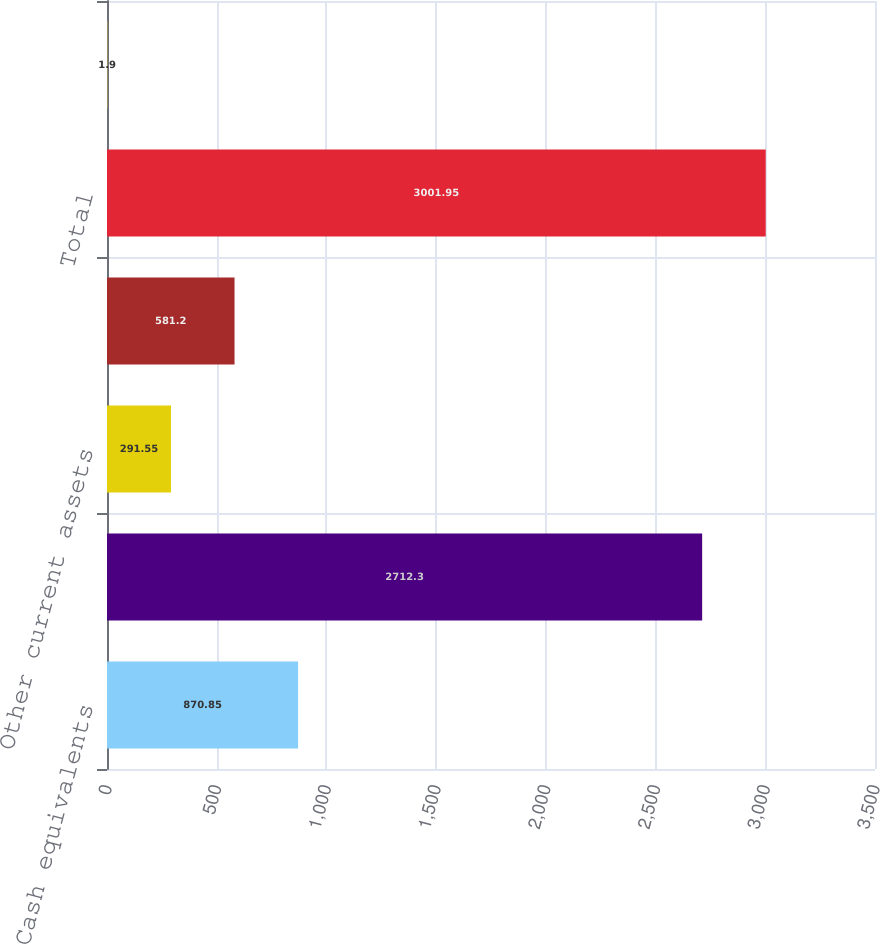<chart> <loc_0><loc_0><loc_500><loc_500><bar_chart><fcel>Cash equivalents<fcel>Short-term investments<fcel>Other current assets<fcel>Other non-current assets<fcel>Total<fcel>Other current liabilities<nl><fcel>870.85<fcel>2712.3<fcel>291.55<fcel>581.2<fcel>3001.95<fcel>1.9<nl></chart> 